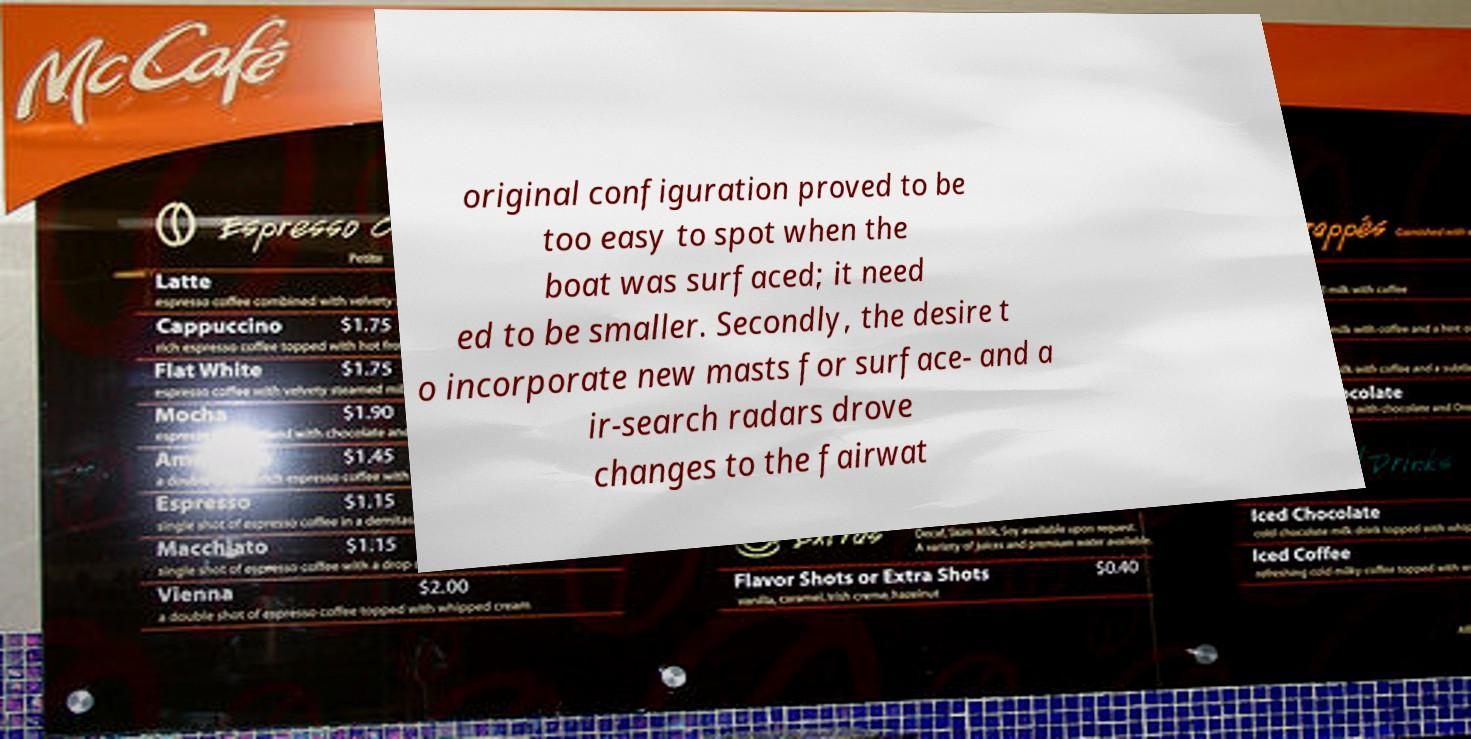Can you read and provide the text displayed in the image?This photo seems to have some interesting text. Can you extract and type it out for me? original configuration proved to be too easy to spot when the boat was surfaced; it need ed to be smaller. Secondly, the desire t o incorporate new masts for surface- and a ir-search radars drove changes to the fairwat 